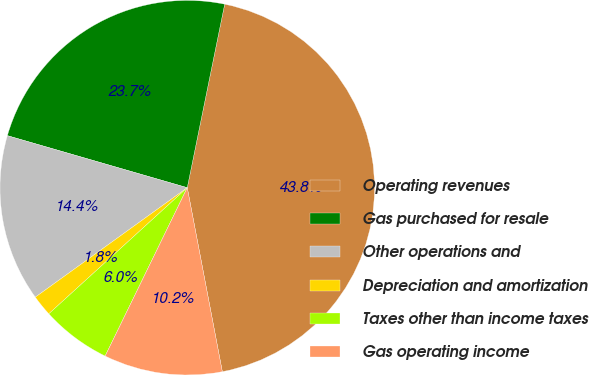Convert chart. <chart><loc_0><loc_0><loc_500><loc_500><pie_chart><fcel>Operating revenues<fcel>Gas purchased for resale<fcel>Other operations and<fcel>Depreciation and amortization<fcel>Taxes other than income taxes<fcel>Gas operating income<nl><fcel>43.8%<fcel>23.72%<fcel>14.42%<fcel>1.82%<fcel>6.02%<fcel>10.22%<nl></chart> 